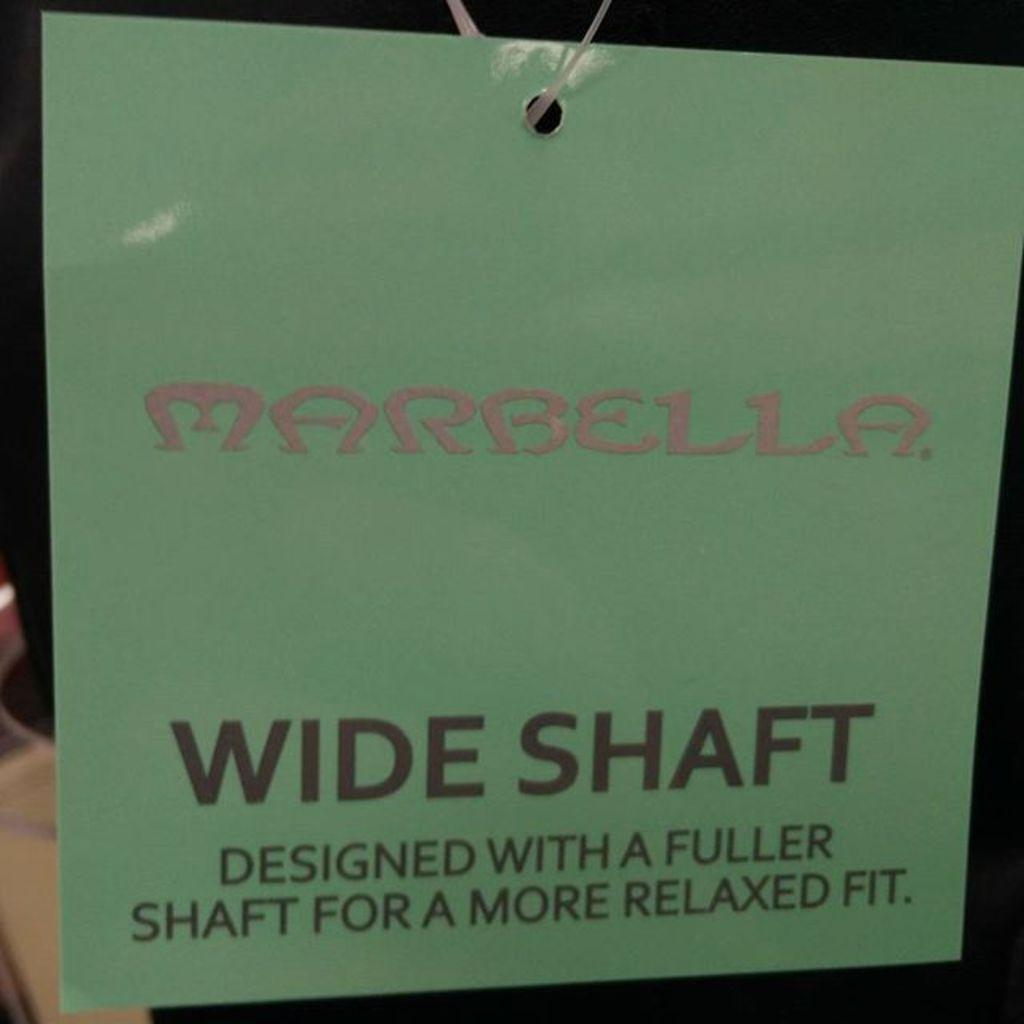<image>
Summarize the visual content of the image. A tag with the brand Marbella on it that has a wide shaft for a more relaxed fit. 